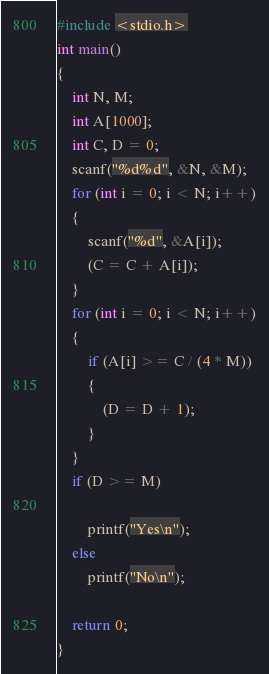Convert code to text. <code><loc_0><loc_0><loc_500><loc_500><_C_>#include <stdio.h>
int main()
{
    int N, M;
    int A[1000];
    int C, D = 0;
    scanf("%d%d", &N, &M);
    for (int i = 0; i < N; i++)
    {
        scanf("%d", &A[i]);
        (C = C + A[i]);
    }
    for (int i = 0; i < N; i++)
    {
        if (A[i] >= C / (4 * M))
        {
            (D = D + 1);
        }
    }
    if (D >= M)

        printf("Yes\n");
    else
        printf("No\n");

    return 0;
}</code> 